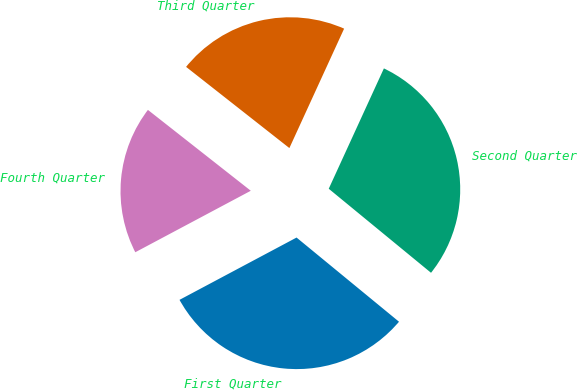<chart> <loc_0><loc_0><loc_500><loc_500><pie_chart><fcel>First Quarter<fcel>Second Quarter<fcel>Third Quarter<fcel>Fourth Quarter<nl><fcel>31.27%<fcel>29.11%<fcel>21.24%<fcel>18.39%<nl></chart> 